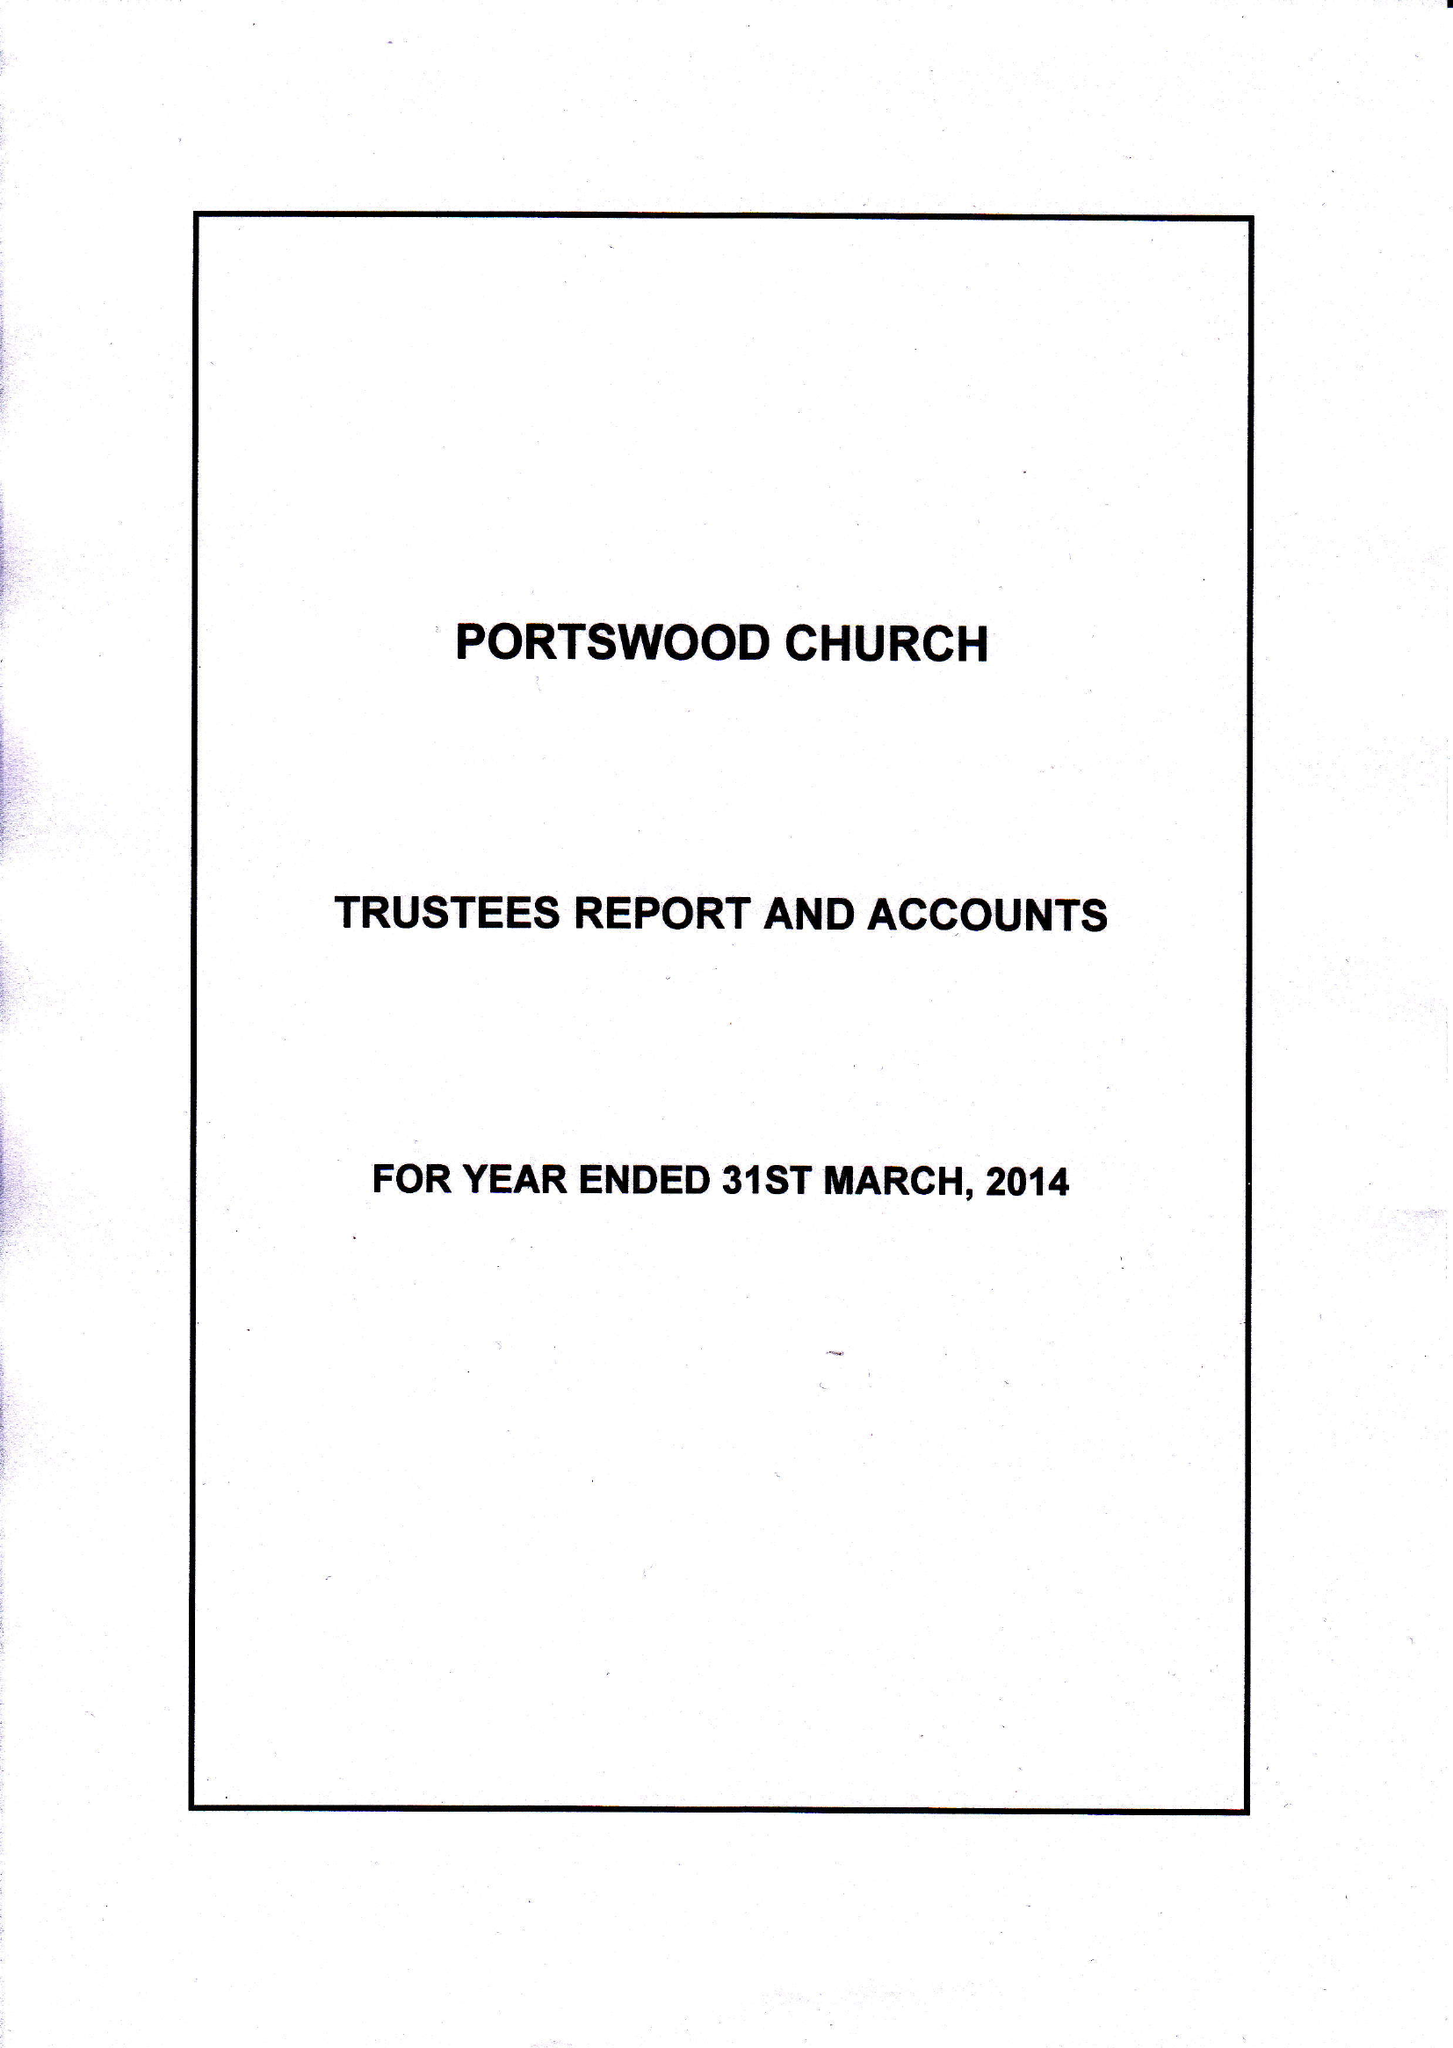What is the value for the spending_annually_in_british_pounds?
Answer the question using a single word or phrase. 252808.00 